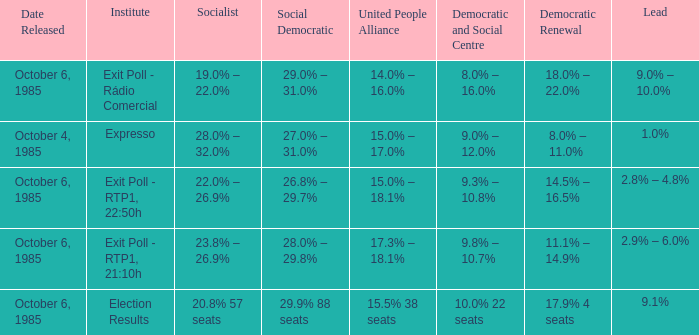Which institutes gave the democratic renewal 18.0% – 22.0% on a poll from october 6, 1985? Exit Poll - Rádio Comercial. 